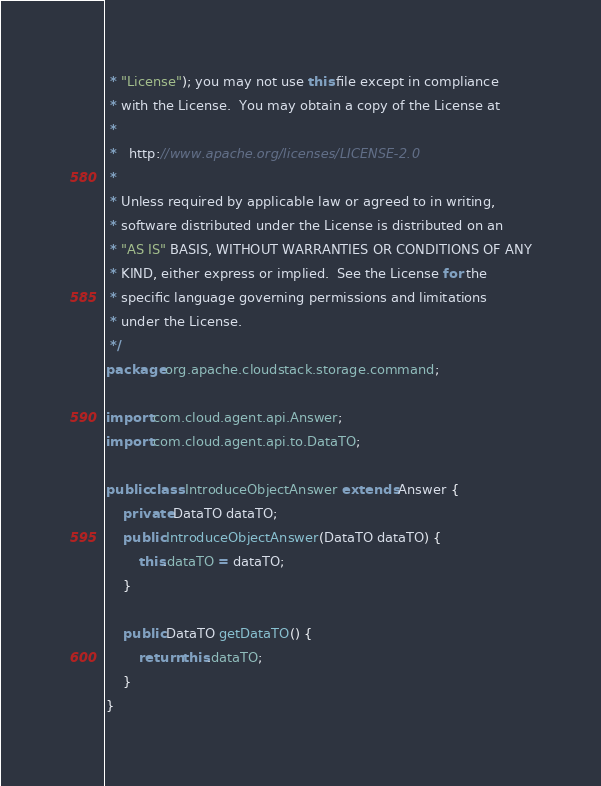<code> <loc_0><loc_0><loc_500><loc_500><_Java_> * "License"); you may not use this file except in compliance
 * with the License.  You may obtain a copy of the License at
 *
 *   http://www.apache.org/licenses/LICENSE-2.0
 *
 * Unless required by applicable law or agreed to in writing,
 * software distributed under the License is distributed on an
 * "AS IS" BASIS, WITHOUT WARRANTIES OR CONDITIONS OF ANY
 * KIND, either express or implied.  See the License for the
 * specific language governing permissions and limitations
 * under the License.
 */
package org.apache.cloudstack.storage.command;

import com.cloud.agent.api.Answer;
import com.cloud.agent.api.to.DataTO;

public class IntroduceObjectAnswer extends Answer {
    private DataTO dataTO;
    public IntroduceObjectAnswer(DataTO dataTO) {
        this.dataTO = dataTO;
    }

    public DataTO getDataTO() {
        return this.dataTO;
    }
}
</code> 